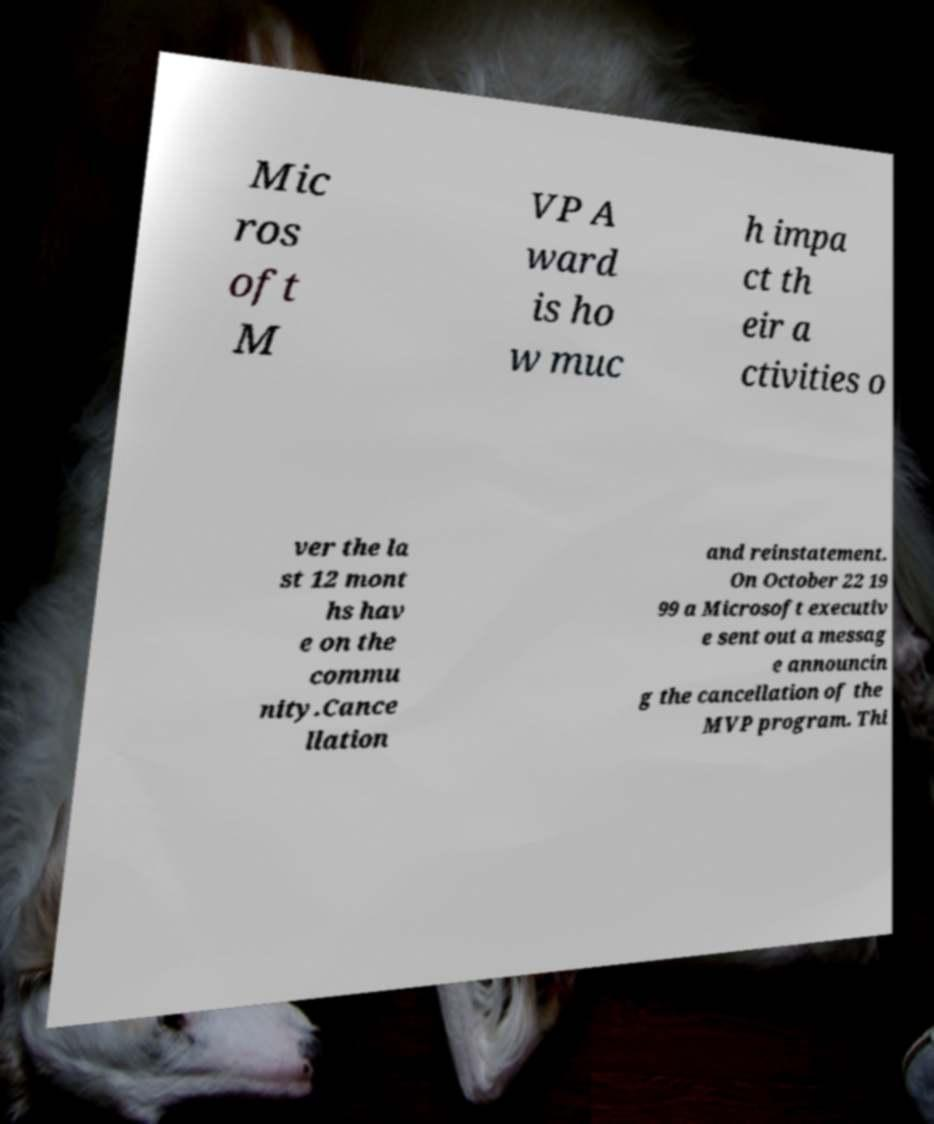Please identify and transcribe the text found in this image. Mic ros oft M VP A ward is ho w muc h impa ct th eir a ctivities o ver the la st 12 mont hs hav e on the commu nity.Cance llation and reinstatement. On October 22 19 99 a Microsoft executiv e sent out a messag e announcin g the cancellation of the MVP program. Thi 